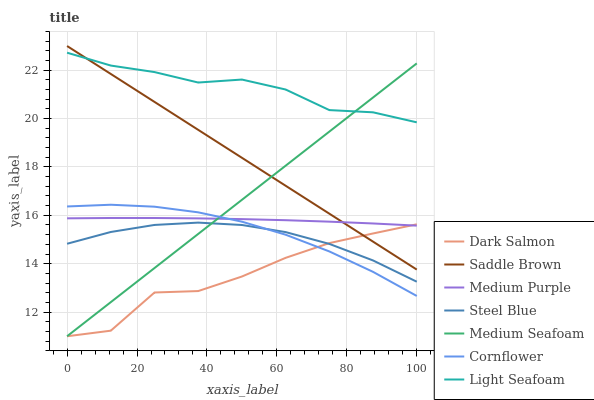Does Dark Salmon have the minimum area under the curve?
Answer yes or no. Yes. Does Light Seafoam have the maximum area under the curve?
Answer yes or no. Yes. Does Steel Blue have the minimum area under the curve?
Answer yes or no. No. Does Steel Blue have the maximum area under the curve?
Answer yes or no. No. Is Saddle Brown the smoothest?
Answer yes or no. Yes. Is Dark Salmon the roughest?
Answer yes or no. Yes. Is Steel Blue the smoothest?
Answer yes or no. No. Is Steel Blue the roughest?
Answer yes or no. No. Does Dark Salmon have the lowest value?
Answer yes or no. Yes. Does Steel Blue have the lowest value?
Answer yes or no. No. Does Saddle Brown have the highest value?
Answer yes or no. Yes. Does Steel Blue have the highest value?
Answer yes or no. No. Is Steel Blue less than Medium Purple?
Answer yes or no. Yes. Is Light Seafoam greater than Dark Salmon?
Answer yes or no. Yes. Does Dark Salmon intersect Steel Blue?
Answer yes or no. Yes. Is Dark Salmon less than Steel Blue?
Answer yes or no. No. Is Dark Salmon greater than Steel Blue?
Answer yes or no. No. Does Steel Blue intersect Medium Purple?
Answer yes or no. No. 